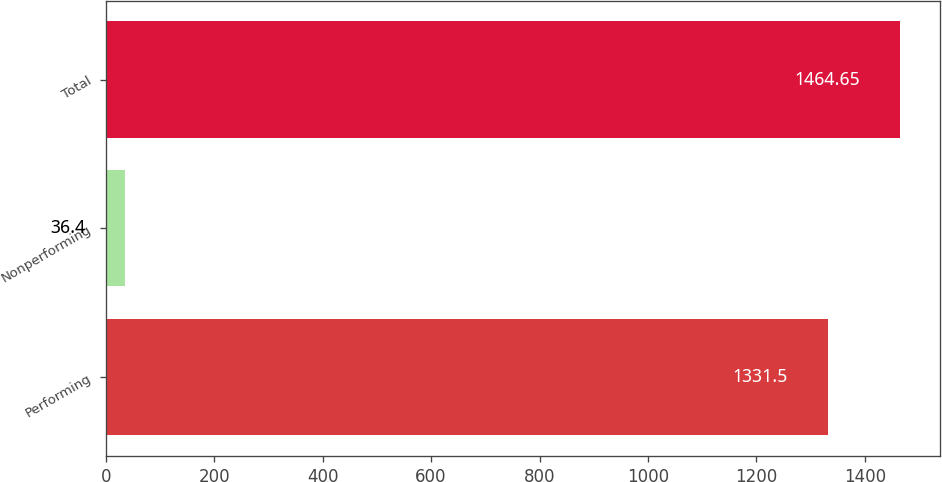<chart> <loc_0><loc_0><loc_500><loc_500><bar_chart><fcel>Performing<fcel>Nonperforming<fcel>Total<nl><fcel>1331.5<fcel>36.4<fcel>1464.65<nl></chart> 